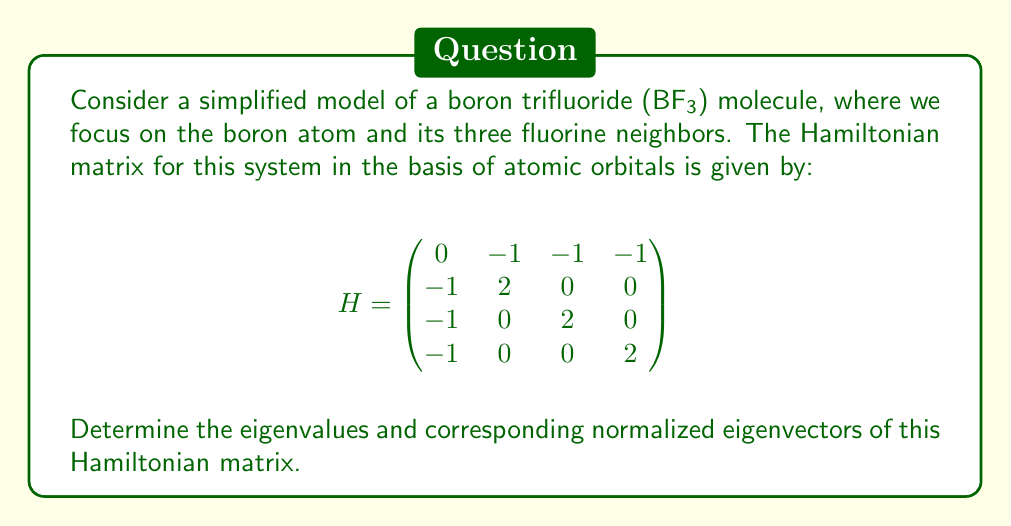What is the answer to this math problem? To find the eigenvalues and eigenvectors of the Hamiltonian matrix, we follow these steps:

1) First, we find the eigenvalues by solving the characteristic equation:
   $$\det(H - \lambda I) = 0$$

2) Expanding the determinant:
   $$\begin{vmatrix}
   -\lambda & -1 & -1 & -1 \\
   -1 & 2-\lambda & 0 & 0 \\
   -1 & 0 & 2-\lambda & 0 \\
   -1 & 0 & 0 & 2-\lambda
   \end{vmatrix} = 0$$

3) This gives us the characteristic polynomial:
   $$-\lambda(2-\lambda)^3 + 3(2-\lambda) = 0$$
   $$(2-\lambda)[-\lambda(2-\lambda)^2 + 3] = 0$$

4) Solving this equation:
   $\lambda = 2$ (with algebraic multiplicity 2)
   $\lambda = 2 \pm \sqrt{3}$

5) Now, we find the eigenvectors for each eigenvalue:

   For $\lambda_1 = 2 + \sqrt{3}$:
   $$(H - \lambda_1 I)\mathbf{v}_1 = \mathbf{0}$$
   Solving this system gives: $\mathbf{v}_1 = (1, \frac{1}{\sqrt{3}}, \frac{1}{\sqrt{3}}, \frac{1}{\sqrt{3}})^T$

   For $\lambda_2 = 2 - \sqrt{3}$:
   $$(H - \lambda_2 I)\mathbf{v}_2 = \mathbf{0}$$
   Solving this system gives: $\mathbf{v}_2 = (1, -\frac{1}{\sqrt{3}}, -\frac{1}{\sqrt{3}}, -\frac{1}{\sqrt{3}})^T$

   For $\lambda_3 = \lambda_4 = 2$:
   $$(H - 2I)\mathbf{v}_3 = \mathbf{0}$$
   Solving this system gives two linearly independent eigenvectors:
   $\mathbf{v}_3 = (0, 1, -1, 0)^T$ and $\mathbf{v}_4 = (0, 1, 0, -1)^T$

6) Normalizing these eigenvectors:
   $\mathbf{v}_1$ and $\mathbf{v}_2$ are already normalized.
   $\mathbf{v}_3$ becomes $\frac{1}{\sqrt{2}}(0, 1, -1, 0)^T$
   $\mathbf{v}_4$ becomes $\frac{1}{\sqrt{2}}(0, 1, 0, -1)^T$
Answer: Eigenvalues: $\lambda_1 = 2 + \sqrt{3}$, $\lambda_2 = 2 - \sqrt{3}$, $\lambda_3 = \lambda_4 = 2$
Normalized eigenvectors: $\mathbf{v}_1 = (1, \frac{1}{\sqrt{3}}, \frac{1}{\sqrt{3}}, \frac{1}{\sqrt{3}})^T$, $\mathbf{v}_2 = (1, -\frac{1}{\sqrt{3}}, -\frac{1}{\sqrt{3}}, -\frac{1}{\sqrt{3}})^T$, $\mathbf{v}_3 = \frac{1}{\sqrt{2}}(0, 1, -1, 0)^T$, $\mathbf{v}_4 = \frac{1}{\sqrt{2}}(0, 1, 0, -1)^T$ 